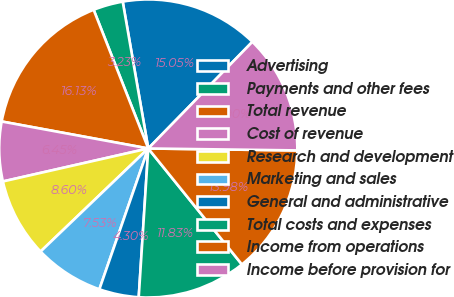Convert chart to OTSL. <chart><loc_0><loc_0><loc_500><loc_500><pie_chart><fcel>Advertising<fcel>Payments and other fees<fcel>Total revenue<fcel>Cost of revenue<fcel>Research and development<fcel>Marketing and sales<fcel>General and administrative<fcel>Total costs and expenses<fcel>Income from operations<fcel>Income before provision for<nl><fcel>15.05%<fcel>3.23%<fcel>16.13%<fcel>6.45%<fcel>8.6%<fcel>7.53%<fcel>4.3%<fcel>11.83%<fcel>13.98%<fcel>12.9%<nl></chart> 